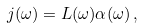<formula> <loc_0><loc_0><loc_500><loc_500>j ( \omega ) = L ( \omega ) \alpha ( \omega ) \, ,</formula> 